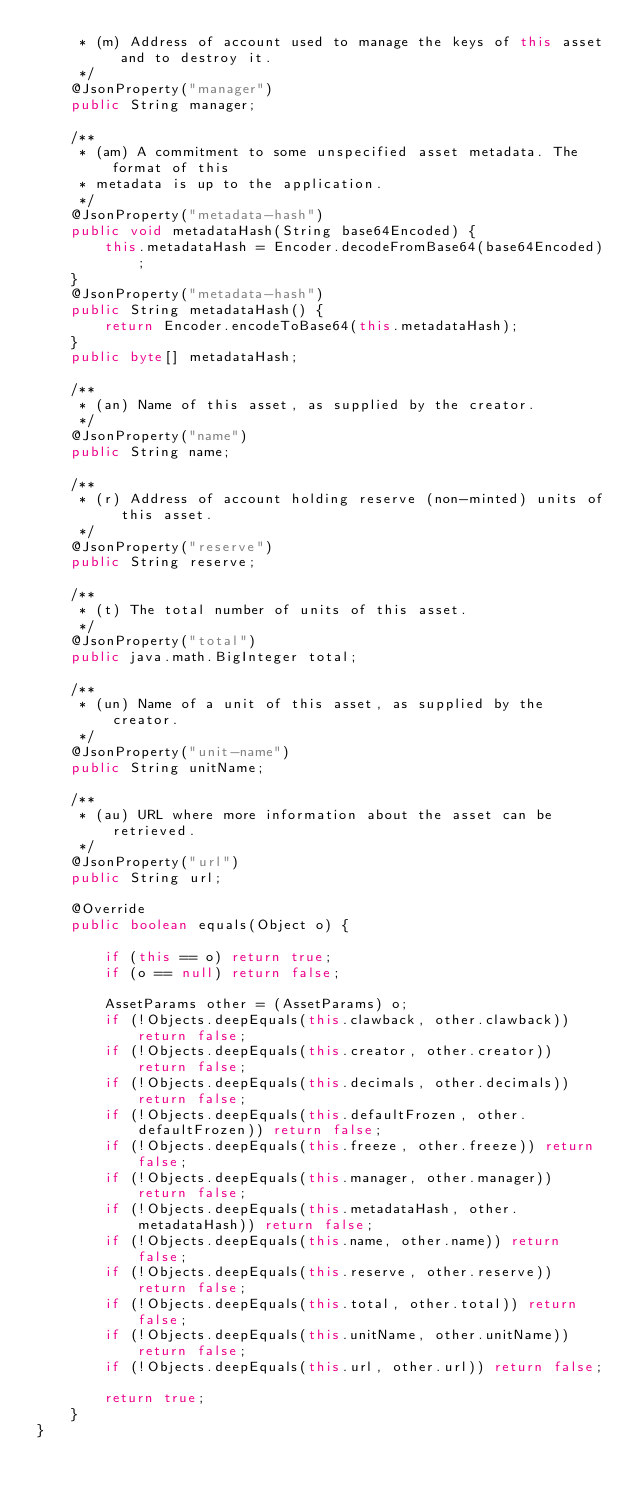Convert code to text. <code><loc_0><loc_0><loc_500><loc_500><_Java_>	 * (m) Address of account used to manage the keys of this asset and to destroy it. 
	 */
	@JsonProperty("manager")
	public String manager;

	/**
	 * (am) A commitment to some unspecified asset metadata. The format of this 
	 * metadata is up to the application. 
	 */
	@JsonProperty("metadata-hash")
	public void metadataHash(String base64Encoded) {
		this.metadataHash = Encoder.decodeFromBase64(base64Encoded);
	}
	@JsonProperty("metadata-hash")
	public String metadataHash() {
		return Encoder.encodeToBase64(this.metadataHash);
	}
	public byte[] metadataHash;

	/**
	 * (an) Name of this asset, as supplied by the creator. 
	 */
	@JsonProperty("name")
	public String name;

	/**
	 * (r) Address of account holding reserve (non-minted) units of this asset. 
	 */
	@JsonProperty("reserve")
	public String reserve;

	/**
	 * (t) The total number of units of this asset. 
	 */
	@JsonProperty("total")
	public java.math.BigInteger total;

	/**
	 * (un) Name of a unit of this asset, as supplied by the creator. 
	 */
	@JsonProperty("unit-name")
	public String unitName;

	/**
	 * (au) URL where more information about the asset can be retrieved. 
	 */
	@JsonProperty("url")
	public String url;

	@Override
	public boolean equals(Object o) {

		if (this == o) return true;
		if (o == null) return false;

		AssetParams other = (AssetParams) o;
		if (!Objects.deepEquals(this.clawback, other.clawback)) return false;
		if (!Objects.deepEquals(this.creator, other.creator)) return false;
		if (!Objects.deepEquals(this.decimals, other.decimals)) return false;
		if (!Objects.deepEquals(this.defaultFrozen, other.defaultFrozen)) return false;
		if (!Objects.deepEquals(this.freeze, other.freeze)) return false;
		if (!Objects.deepEquals(this.manager, other.manager)) return false;
		if (!Objects.deepEquals(this.metadataHash, other.metadataHash)) return false;
		if (!Objects.deepEquals(this.name, other.name)) return false;
		if (!Objects.deepEquals(this.reserve, other.reserve)) return false;
		if (!Objects.deepEquals(this.total, other.total)) return false;
		if (!Objects.deepEquals(this.unitName, other.unitName)) return false;
		if (!Objects.deepEquals(this.url, other.url)) return false;

		return true;
	}
}
</code> 